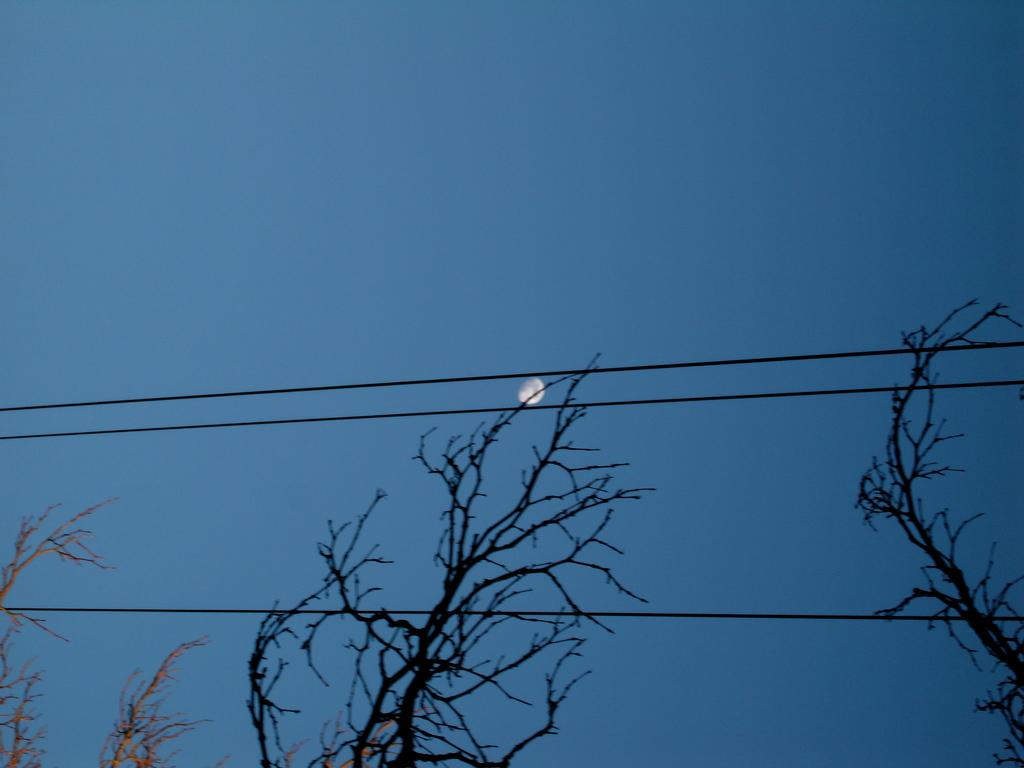What can be seen at the bottom of the image? There are trees and wires at the bottom of the image. What celestial body is visible in the sky? The moon is visible in the sky. What type of sweater is draped over the desk in the image? There is no sweater or desk present in the image. What country is depicted in the image? The image does not depict any specific country. 